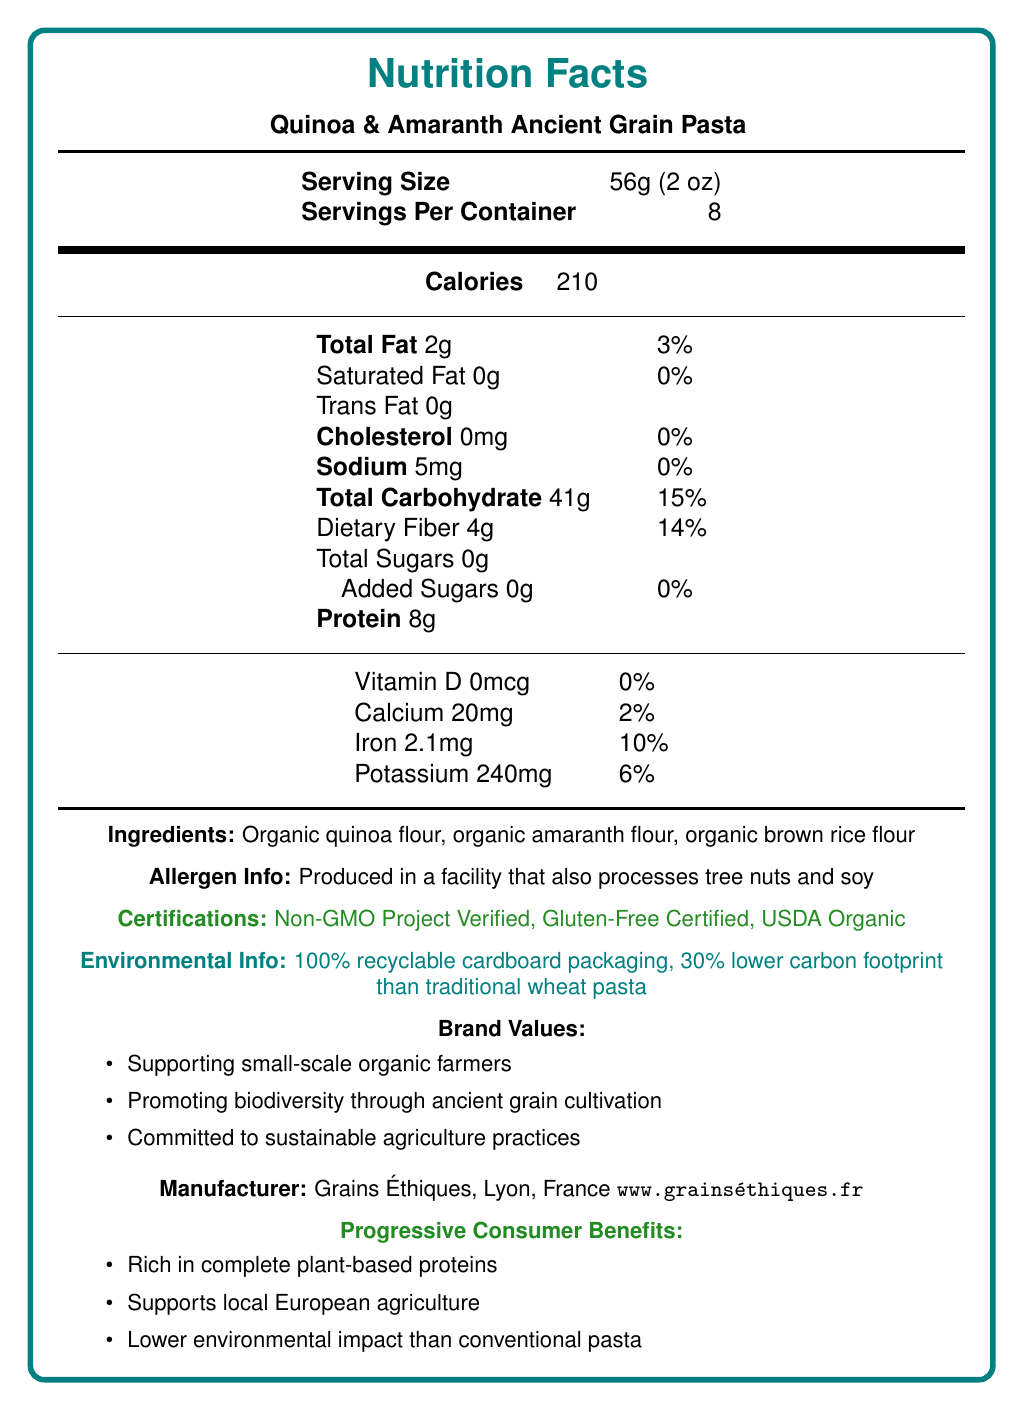what is the serving size? The document specifies the serving size as 56g (2 oz).
Answer: 56g (2 oz) how many servings are there in one container? The document states that there are 8 servings per container.
Answer: 8 what is the amount of protein in one serving? The document indicates that one serving contains 8g of protein.
Answer: 8g what are the ingredients used in this pasta? The ingredients listed in the document are organic quinoa flour, organic amaranth flour, and organic brown rice flour.
Answer: Organic quinoa flour, organic amaranth flour, organic brown rice flour how much dietary fiber does one serving provide? The nutrition facts label shows that one serving contains 4g of dietary fiber.
Answer: 4g which vitamin is present in the highest percent daily value? A. Vitamin D B. Calcium C. Iron D. Potassium The document shows that Iron has a 10% daily value, which is higher than Calcium (2%), Potassium (6%), and Vitamin D (0%).
Answer: C. Iron what is the carbon footprint reduction of this pasta compared to traditional wheat pasta? A. 10% lower B. 20% lower C. 30% lower D. 50% lower The environmental info in the document states that the carbon footprint is 30% lower compared to traditional wheat pasta.
Answer: C. 30% lower is this pasta produced in a gluten-free certified facility? The document lists "Gluten-Free Certified" under certifications.
Answer: Yes what are some of the benefits for progressive consumers mentioned in the document? The document lists benefits for progressive consumers as being rich in complete plant-based proteins, supporting local European agriculture, and having a lower environmental impact than conventional pasta.
Answer: Rich in complete plant-based proteins, Supports local European agriculture, Lower environmental impact than conventional pasta. does this pasta contain any added sugars? The nutrition facts show that there are 0g of added sugars per serving.
Answer: No who is the manufacturer of Quinoa & Amaranth Ancient Grain Pasta? According to the document, the manufacturer is Grains Éthiques located in Lyon, France.
Answer: Grains Éthiques what allergies should be considered when consuming this pasta? The allergen info in the document states that the product is produced in a facility that processes tree nuts and soy.
Answer: Tree nuts and soy can you summarize the main idea of the document? The document provides detailed nutrition facts, certifications, environmental benefits, and brand values, positioning the product as a healthy and eco-friendly choice.
Answer: Quinoa & Amaranth Ancient Grain Pasta is a nutritious, non-GMO, gluten-free product with certifications for sustainability and organic farming. It is rich in plant-based proteins and supports progressive values such as local European agriculture and reduced environmental impact. what is the brand name that sells this pasta? The document does not provide a specific brand name beyond the manufacturer's information, Grains Éthiques.
Answer: Cannot be determined 